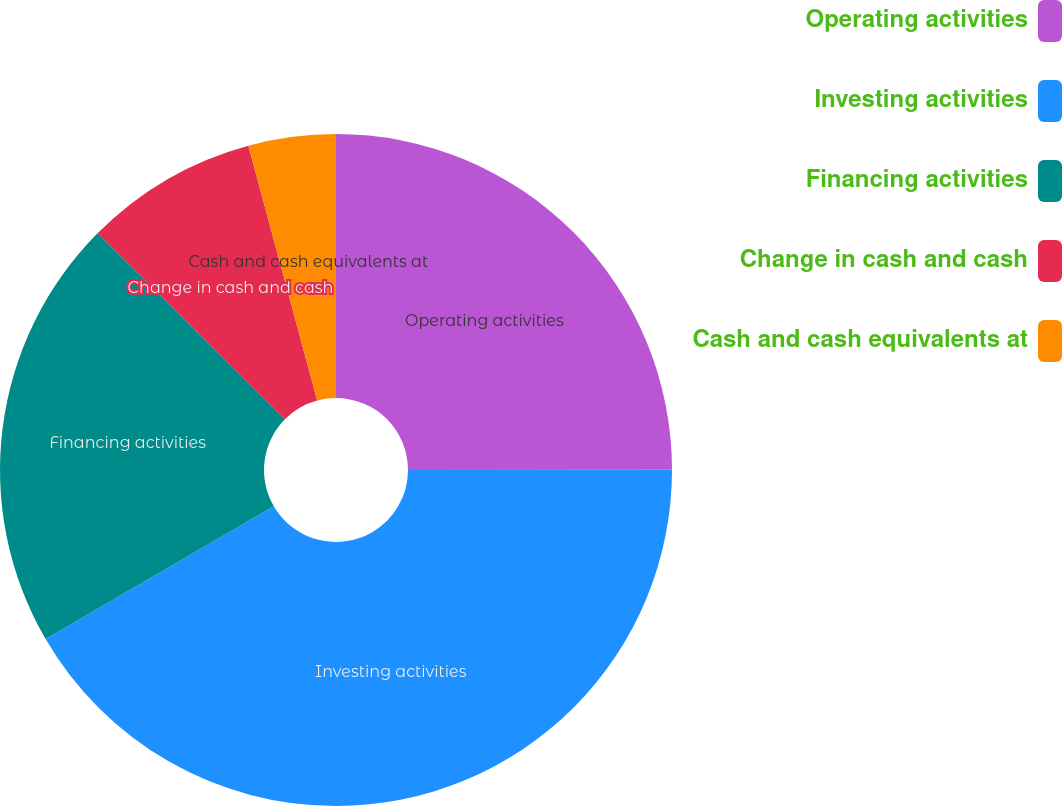<chart> <loc_0><loc_0><loc_500><loc_500><pie_chart><fcel>Operating activities<fcel>Investing activities<fcel>Financing activities<fcel>Change in cash and cash<fcel>Cash and cash equivalents at<nl><fcel>24.99%<fcel>41.62%<fcel>20.83%<fcel>8.36%<fcel>4.2%<nl></chart> 